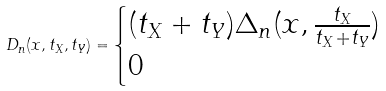<formula> <loc_0><loc_0><loc_500><loc_500>D _ { n } ( x , t _ { X } , t _ { Y } ) = \begin{cases} ( t _ { X } + t _ { Y } ) \Delta _ { n } ( x , \frac { t _ { X } } { t _ { X } + t _ { Y } } ) & \\ 0 & \end{cases}</formula> 